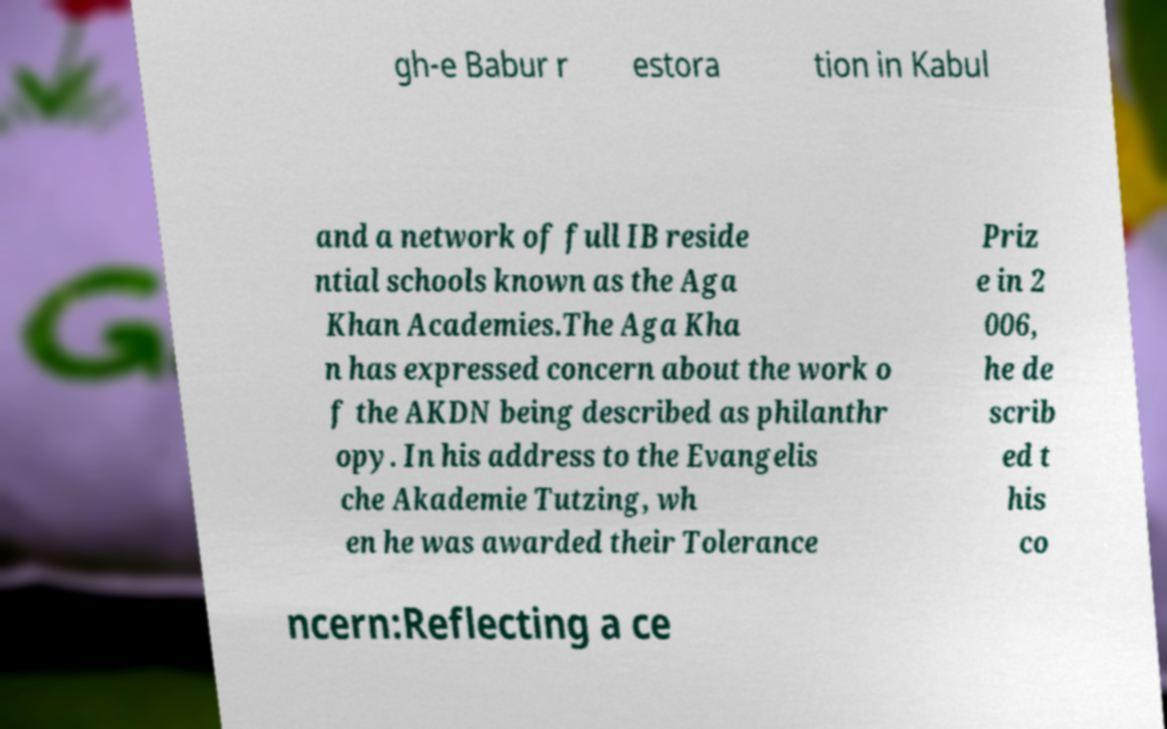Can you accurately transcribe the text from the provided image for me? gh-e Babur r estora tion in Kabul and a network of full IB reside ntial schools known as the Aga Khan Academies.The Aga Kha n has expressed concern about the work o f the AKDN being described as philanthr opy. In his address to the Evangelis che Akademie Tutzing, wh en he was awarded their Tolerance Priz e in 2 006, he de scrib ed t his co ncern:Reflecting a ce 